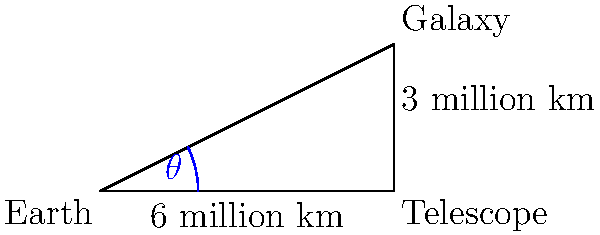In a science fiction novel, an astronomer observes a distant galaxy through a powerful space telescope. The telescope is positioned 6 million kilometers from Earth, and the galaxy is 3 million kilometers above the line connecting Earth and the telescope. What is the angle of view ($\theta$) from Earth to the galaxy, rounded to the nearest hundredth of a degree? To solve this problem, we'll use trigonometry:

1. The situation forms a right-angled triangle with Earth at the origin, the telescope on the x-axis, and the galaxy at the top of the triangle.

2. We need to find the angle $\theta$ at the Earth (origin).

3. We can use the arctangent function to calculate this angle:

   $\theta = \arctan(\frac{\text{opposite}}{\text{adjacent}})$

4. The opposite side is 3 million km (height of the galaxy above the Earth-telescope line).
   The adjacent side is 6 million km (distance from Earth to the telescope).

5. Substituting these values:

   $\theta = \arctan(\frac{3}{6}) = \arctan(0.5)$

6. Calculate this value:
   
   $\theta \approx 26.5650512$ degrees

7. Rounding to the nearest hundredth:
   
   $\theta \approx 26.57$ degrees

This angle represents the view from Earth to the galaxy, taking into account the telescope's position.
Answer: $26.57^\circ$ 